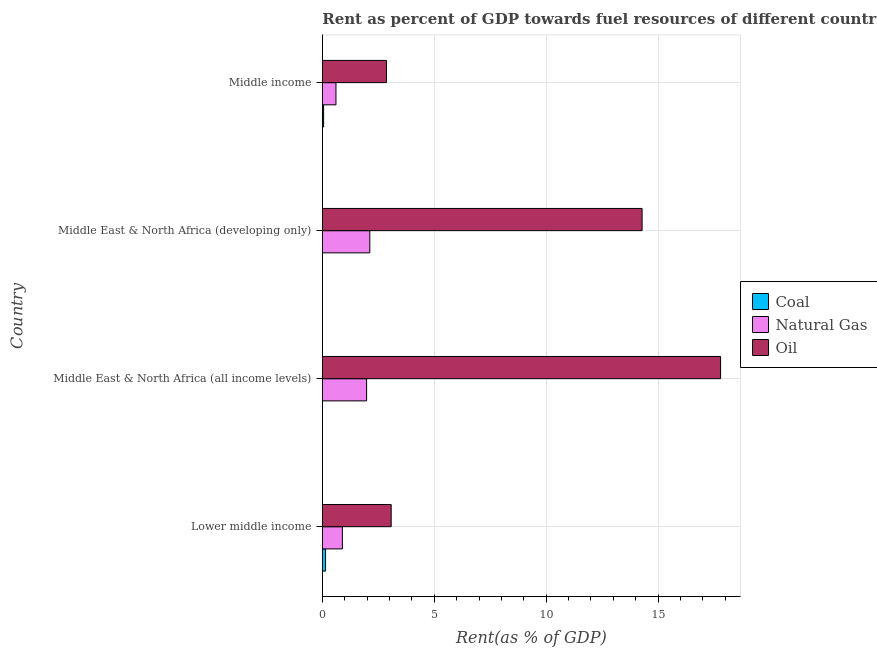How many different coloured bars are there?
Give a very brief answer. 3. How many groups of bars are there?
Keep it short and to the point. 4. How many bars are there on the 2nd tick from the top?
Provide a succinct answer. 3. What is the label of the 3rd group of bars from the top?
Provide a short and direct response. Middle East & North Africa (all income levels). What is the rent towards natural gas in Middle East & North Africa (developing only)?
Provide a succinct answer. 2.12. Across all countries, what is the maximum rent towards coal?
Provide a short and direct response. 0.14. Across all countries, what is the minimum rent towards coal?
Offer a terse response. 0. In which country was the rent towards natural gas maximum?
Ensure brevity in your answer.  Middle East & North Africa (developing only). What is the total rent towards coal in the graph?
Give a very brief answer. 0.21. What is the difference between the rent towards natural gas in Middle East & North Africa (all income levels) and that in Middle income?
Your response must be concise. 1.37. What is the difference between the rent towards coal in Middle income and the rent towards oil in Middle East & North Africa (all income levels)?
Provide a succinct answer. -17.73. What is the average rent towards natural gas per country?
Ensure brevity in your answer.  1.4. What is the difference between the rent towards natural gas and rent towards coal in Lower middle income?
Your answer should be very brief. 0.75. In how many countries, is the rent towards natural gas greater than 1 %?
Your response must be concise. 2. What is the ratio of the rent towards natural gas in Middle East & North Africa (developing only) to that in Middle income?
Your answer should be compact. 3.48. Is the difference between the rent towards oil in Lower middle income and Middle income greater than the difference between the rent towards natural gas in Lower middle income and Middle income?
Provide a succinct answer. No. What is the difference between the highest and the second highest rent towards coal?
Offer a very short reply. 0.09. What is the difference between the highest and the lowest rent towards oil?
Your response must be concise. 14.93. In how many countries, is the rent towards oil greater than the average rent towards oil taken over all countries?
Provide a succinct answer. 2. Is the sum of the rent towards oil in Lower middle income and Middle East & North Africa (developing only) greater than the maximum rent towards coal across all countries?
Your answer should be very brief. Yes. What does the 3rd bar from the top in Lower middle income represents?
Ensure brevity in your answer.  Coal. What does the 3rd bar from the bottom in Middle East & North Africa (all income levels) represents?
Offer a terse response. Oil. What is the difference between two consecutive major ticks on the X-axis?
Provide a short and direct response. 5. Are the values on the major ticks of X-axis written in scientific E-notation?
Offer a terse response. No. Does the graph contain any zero values?
Your response must be concise. No. Does the graph contain grids?
Offer a very short reply. Yes. What is the title of the graph?
Offer a very short reply. Rent as percent of GDP towards fuel resources of different countries in 1994. Does "Oil" appear as one of the legend labels in the graph?
Ensure brevity in your answer.  Yes. What is the label or title of the X-axis?
Your answer should be compact. Rent(as % of GDP). What is the Rent(as % of GDP) in Coal in Lower middle income?
Ensure brevity in your answer.  0.14. What is the Rent(as % of GDP) of Natural Gas in Lower middle income?
Your answer should be very brief. 0.9. What is the Rent(as % of GDP) of Oil in Lower middle income?
Your answer should be very brief. 3.08. What is the Rent(as % of GDP) in Coal in Middle East & North Africa (all income levels)?
Ensure brevity in your answer.  0. What is the Rent(as % of GDP) in Natural Gas in Middle East & North Africa (all income levels)?
Your answer should be very brief. 1.98. What is the Rent(as % of GDP) in Oil in Middle East & North Africa (all income levels)?
Offer a very short reply. 17.79. What is the Rent(as % of GDP) of Coal in Middle East & North Africa (developing only)?
Your answer should be compact. 0. What is the Rent(as % of GDP) of Natural Gas in Middle East & North Africa (developing only)?
Offer a very short reply. 2.12. What is the Rent(as % of GDP) of Oil in Middle East & North Africa (developing only)?
Offer a terse response. 14.28. What is the Rent(as % of GDP) in Coal in Middle income?
Make the answer very short. 0.06. What is the Rent(as % of GDP) in Natural Gas in Middle income?
Your response must be concise. 0.61. What is the Rent(as % of GDP) of Oil in Middle income?
Offer a terse response. 2.87. Across all countries, what is the maximum Rent(as % of GDP) in Coal?
Provide a short and direct response. 0.14. Across all countries, what is the maximum Rent(as % of GDP) in Natural Gas?
Provide a succinct answer. 2.12. Across all countries, what is the maximum Rent(as % of GDP) in Oil?
Your answer should be compact. 17.79. Across all countries, what is the minimum Rent(as % of GDP) of Coal?
Your answer should be compact. 0. Across all countries, what is the minimum Rent(as % of GDP) of Natural Gas?
Give a very brief answer. 0.61. Across all countries, what is the minimum Rent(as % of GDP) in Oil?
Ensure brevity in your answer.  2.87. What is the total Rent(as % of GDP) of Coal in the graph?
Ensure brevity in your answer.  0.21. What is the total Rent(as % of GDP) of Natural Gas in the graph?
Provide a succinct answer. 5.6. What is the total Rent(as % of GDP) of Oil in the graph?
Offer a very short reply. 38.02. What is the difference between the Rent(as % of GDP) in Coal in Lower middle income and that in Middle East & North Africa (all income levels)?
Offer a terse response. 0.14. What is the difference between the Rent(as % of GDP) of Natural Gas in Lower middle income and that in Middle East & North Africa (all income levels)?
Keep it short and to the point. -1.08. What is the difference between the Rent(as % of GDP) in Oil in Lower middle income and that in Middle East & North Africa (all income levels)?
Make the answer very short. -14.72. What is the difference between the Rent(as % of GDP) of Coal in Lower middle income and that in Middle East & North Africa (developing only)?
Ensure brevity in your answer.  0.14. What is the difference between the Rent(as % of GDP) in Natural Gas in Lower middle income and that in Middle East & North Africa (developing only)?
Your answer should be compact. -1.23. What is the difference between the Rent(as % of GDP) in Oil in Lower middle income and that in Middle East & North Africa (developing only)?
Provide a short and direct response. -11.21. What is the difference between the Rent(as % of GDP) of Coal in Lower middle income and that in Middle income?
Provide a short and direct response. 0.09. What is the difference between the Rent(as % of GDP) in Natural Gas in Lower middle income and that in Middle income?
Offer a terse response. 0.29. What is the difference between the Rent(as % of GDP) in Oil in Lower middle income and that in Middle income?
Offer a terse response. 0.21. What is the difference between the Rent(as % of GDP) in Coal in Middle East & North Africa (all income levels) and that in Middle East & North Africa (developing only)?
Offer a terse response. -0. What is the difference between the Rent(as % of GDP) in Natural Gas in Middle East & North Africa (all income levels) and that in Middle East & North Africa (developing only)?
Provide a succinct answer. -0.14. What is the difference between the Rent(as % of GDP) in Oil in Middle East & North Africa (all income levels) and that in Middle East & North Africa (developing only)?
Offer a terse response. 3.51. What is the difference between the Rent(as % of GDP) in Coal in Middle East & North Africa (all income levels) and that in Middle income?
Your response must be concise. -0.06. What is the difference between the Rent(as % of GDP) of Natural Gas in Middle East & North Africa (all income levels) and that in Middle income?
Provide a succinct answer. 1.37. What is the difference between the Rent(as % of GDP) in Oil in Middle East & North Africa (all income levels) and that in Middle income?
Offer a very short reply. 14.93. What is the difference between the Rent(as % of GDP) of Coal in Middle East & North Africa (developing only) and that in Middle income?
Offer a very short reply. -0.06. What is the difference between the Rent(as % of GDP) in Natural Gas in Middle East & North Africa (developing only) and that in Middle income?
Give a very brief answer. 1.51. What is the difference between the Rent(as % of GDP) of Oil in Middle East & North Africa (developing only) and that in Middle income?
Your response must be concise. 11.42. What is the difference between the Rent(as % of GDP) of Coal in Lower middle income and the Rent(as % of GDP) of Natural Gas in Middle East & North Africa (all income levels)?
Keep it short and to the point. -1.83. What is the difference between the Rent(as % of GDP) in Coal in Lower middle income and the Rent(as % of GDP) in Oil in Middle East & North Africa (all income levels)?
Offer a very short reply. -17.65. What is the difference between the Rent(as % of GDP) of Natural Gas in Lower middle income and the Rent(as % of GDP) of Oil in Middle East & North Africa (all income levels)?
Keep it short and to the point. -16.9. What is the difference between the Rent(as % of GDP) in Coal in Lower middle income and the Rent(as % of GDP) in Natural Gas in Middle East & North Africa (developing only)?
Provide a short and direct response. -1.98. What is the difference between the Rent(as % of GDP) in Coal in Lower middle income and the Rent(as % of GDP) in Oil in Middle East & North Africa (developing only)?
Provide a succinct answer. -14.14. What is the difference between the Rent(as % of GDP) of Natural Gas in Lower middle income and the Rent(as % of GDP) of Oil in Middle East & North Africa (developing only)?
Your response must be concise. -13.39. What is the difference between the Rent(as % of GDP) in Coal in Lower middle income and the Rent(as % of GDP) in Natural Gas in Middle income?
Your answer should be very brief. -0.46. What is the difference between the Rent(as % of GDP) in Coal in Lower middle income and the Rent(as % of GDP) in Oil in Middle income?
Keep it short and to the point. -2.72. What is the difference between the Rent(as % of GDP) in Natural Gas in Lower middle income and the Rent(as % of GDP) in Oil in Middle income?
Your answer should be compact. -1.97. What is the difference between the Rent(as % of GDP) of Coal in Middle East & North Africa (all income levels) and the Rent(as % of GDP) of Natural Gas in Middle East & North Africa (developing only)?
Your answer should be compact. -2.12. What is the difference between the Rent(as % of GDP) in Coal in Middle East & North Africa (all income levels) and the Rent(as % of GDP) in Oil in Middle East & North Africa (developing only)?
Ensure brevity in your answer.  -14.28. What is the difference between the Rent(as % of GDP) in Natural Gas in Middle East & North Africa (all income levels) and the Rent(as % of GDP) in Oil in Middle East & North Africa (developing only)?
Offer a very short reply. -12.31. What is the difference between the Rent(as % of GDP) in Coal in Middle East & North Africa (all income levels) and the Rent(as % of GDP) in Natural Gas in Middle income?
Offer a terse response. -0.61. What is the difference between the Rent(as % of GDP) of Coal in Middle East & North Africa (all income levels) and the Rent(as % of GDP) of Oil in Middle income?
Keep it short and to the point. -2.86. What is the difference between the Rent(as % of GDP) in Natural Gas in Middle East & North Africa (all income levels) and the Rent(as % of GDP) in Oil in Middle income?
Ensure brevity in your answer.  -0.89. What is the difference between the Rent(as % of GDP) in Coal in Middle East & North Africa (developing only) and the Rent(as % of GDP) in Natural Gas in Middle income?
Provide a short and direct response. -0.61. What is the difference between the Rent(as % of GDP) of Coal in Middle East & North Africa (developing only) and the Rent(as % of GDP) of Oil in Middle income?
Keep it short and to the point. -2.86. What is the difference between the Rent(as % of GDP) of Natural Gas in Middle East & North Africa (developing only) and the Rent(as % of GDP) of Oil in Middle income?
Provide a succinct answer. -0.74. What is the average Rent(as % of GDP) in Coal per country?
Offer a very short reply. 0.05. What is the average Rent(as % of GDP) in Natural Gas per country?
Your response must be concise. 1.4. What is the average Rent(as % of GDP) in Oil per country?
Keep it short and to the point. 9.5. What is the difference between the Rent(as % of GDP) in Coal and Rent(as % of GDP) in Natural Gas in Lower middle income?
Provide a short and direct response. -0.75. What is the difference between the Rent(as % of GDP) in Coal and Rent(as % of GDP) in Oil in Lower middle income?
Keep it short and to the point. -2.93. What is the difference between the Rent(as % of GDP) in Natural Gas and Rent(as % of GDP) in Oil in Lower middle income?
Your response must be concise. -2.18. What is the difference between the Rent(as % of GDP) of Coal and Rent(as % of GDP) of Natural Gas in Middle East & North Africa (all income levels)?
Keep it short and to the point. -1.98. What is the difference between the Rent(as % of GDP) of Coal and Rent(as % of GDP) of Oil in Middle East & North Africa (all income levels)?
Your answer should be very brief. -17.79. What is the difference between the Rent(as % of GDP) of Natural Gas and Rent(as % of GDP) of Oil in Middle East & North Africa (all income levels)?
Your answer should be compact. -15.81. What is the difference between the Rent(as % of GDP) in Coal and Rent(as % of GDP) in Natural Gas in Middle East & North Africa (developing only)?
Your answer should be very brief. -2.12. What is the difference between the Rent(as % of GDP) in Coal and Rent(as % of GDP) in Oil in Middle East & North Africa (developing only)?
Offer a terse response. -14.28. What is the difference between the Rent(as % of GDP) in Natural Gas and Rent(as % of GDP) in Oil in Middle East & North Africa (developing only)?
Offer a very short reply. -12.16. What is the difference between the Rent(as % of GDP) of Coal and Rent(as % of GDP) of Natural Gas in Middle income?
Your answer should be compact. -0.55. What is the difference between the Rent(as % of GDP) in Coal and Rent(as % of GDP) in Oil in Middle income?
Your response must be concise. -2.81. What is the difference between the Rent(as % of GDP) of Natural Gas and Rent(as % of GDP) of Oil in Middle income?
Make the answer very short. -2.26. What is the ratio of the Rent(as % of GDP) in Coal in Lower middle income to that in Middle East & North Africa (all income levels)?
Keep it short and to the point. 149.4. What is the ratio of the Rent(as % of GDP) in Natural Gas in Lower middle income to that in Middle East & North Africa (all income levels)?
Your answer should be compact. 0.45. What is the ratio of the Rent(as % of GDP) of Oil in Lower middle income to that in Middle East & North Africa (all income levels)?
Provide a short and direct response. 0.17. What is the ratio of the Rent(as % of GDP) of Coal in Lower middle income to that in Middle East & North Africa (developing only)?
Your answer should be compact. 69.23. What is the ratio of the Rent(as % of GDP) in Natural Gas in Lower middle income to that in Middle East & North Africa (developing only)?
Your answer should be very brief. 0.42. What is the ratio of the Rent(as % of GDP) of Oil in Lower middle income to that in Middle East & North Africa (developing only)?
Provide a succinct answer. 0.22. What is the ratio of the Rent(as % of GDP) in Coal in Lower middle income to that in Middle income?
Ensure brevity in your answer.  2.52. What is the ratio of the Rent(as % of GDP) in Natural Gas in Lower middle income to that in Middle income?
Keep it short and to the point. 1.47. What is the ratio of the Rent(as % of GDP) of Oil in Lower middle income to that in Middle income?
Your response must be concise. 1.07. What is the ratio of the Rent(as % of GDP) of Coal in Middle East & North Africa (all income levels) to that in Middle East & North Africa (developing only)?
Make the answer very short. 0.46. What is the ratio of the Rent(as % of GDP) in Natural Gas in Middle East & North Africa (all income levels) to that in Middle East & North Africa (developing only)?
Your answer should be compact. 0.93. What is the ratio of the Rent(as % of GDP) of Oil in Middle East & North Africa (all income levels) to that in Middle East & North Africa (developing only)?
Offer a terse response. 1.25. What is the ratio of the Rent(as % of GDP) of Coal in Middle East & North Africa (all income levels) to that in Middle income?
Offer a very short reply. 0.02. What is the ratio of the Rent(as % of GDP) in Natural Gas in Middle East & North Africa (all income levels) to that in Middle income?
Offer a terse response. 3.25. What is the ratio of the Rent(as % of GDP) of Oil in Middle East & North Africa (all income levels) to that in Middle income?
Ensure brevity in your answer.  6.21. What is the ratio of the Rent(as % of GDP) of Coal in Middle East & North Africa (developing only) to that in Middle income?
Keep it short and to the point. 0.04. What is the ratio of the Rent(as % of GDP) of Natural Gas in Middle East & North Africa (developing only) to that in Middle income?
Provide a short and direct response. 3.48. What is the ratio of the Rent(as % of GDP) of Oil in Middle East & North Africa (developing only) to that in Middle income?
Provide a short and direct response. 4.99. What is the difference between the highest and the second highest Rent(as % of GDP) in Coal?
Ensure brevity in your answer.  0.09. What is the difference between the highest and the second highest Rent(as % of GDP) in Natural Gas?
Your answer should be compact. 0.14. What is the difference between the highest and the second highest Rent(as % of GDP) in Oil?
Keep it short and to the point. 3.51. What is the difference between the highest and the lowest Rent(as % of GDP) of Coal?
Offer a very short reply. 0.14. What is the difference between the highest and the lowest Rent(as % of GDP) of Natural Gas?
Provide a succinct answer. 1.51. What is the difference between the highest and the lowest Rent(as % of GDP) of Oil?
Your answer should be compact. 14.93. 